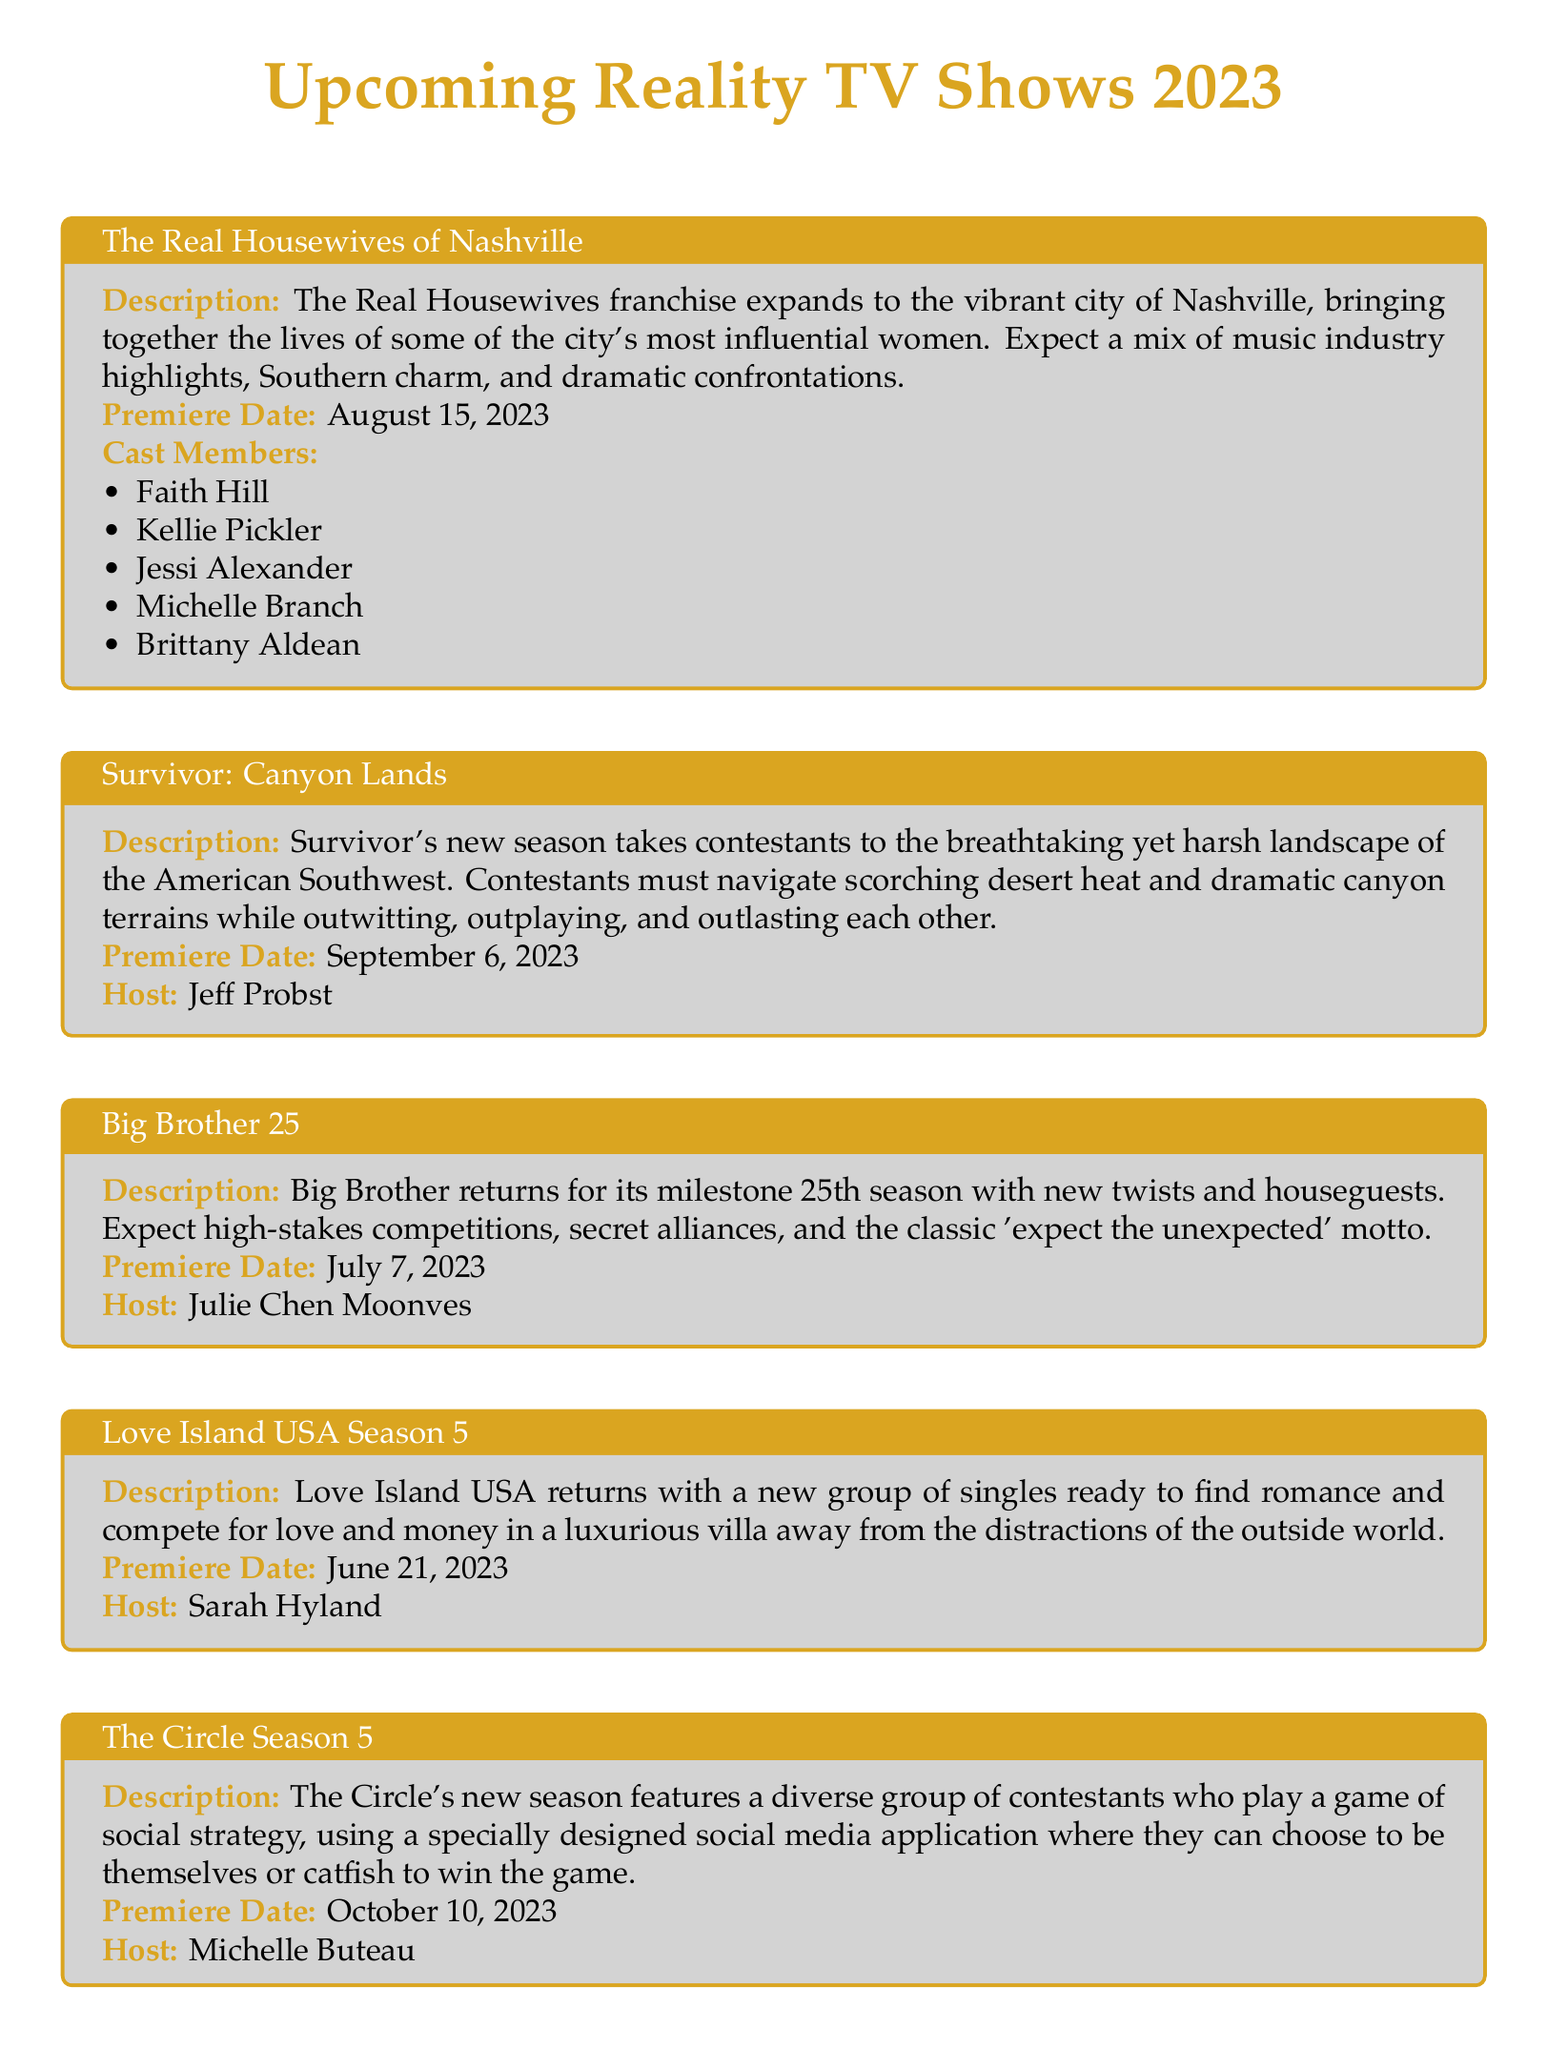What is the premiere date of The Real Housewives of Nashville? The premiere date for The Real Housewives of Nashville is specified in the document.
Answer: August 15, 2023 Who is the host of Survivor: Canyon Lands? The document lists the host for Survivor: Canyon Lands, which is Jeff Probst.
Answer: Jeff Probst How many cast members are in The Real Housewives of Nashville? The document provides a list of cast members for The Real Housewives of Nashville. There are five members listed.
Answer: 5 When does Love Island USA Season 5 premiere? The premiere date for Love Island USA Season 5 is clearly stated in the document.
Answer: June 21, 2023 What is the main theme of The Circle Season 5? The document describes the main theme of The Circle Season 5 as social strategy.
Answer: Social strategy Which show features hosts Tyra Banks and Alfonso Ribeiro? The document indicates that Tyra Banks and Alfonso Ribeiro are the hosts for a specific show.
Answer: Dancing with the Stars Season 32 What type of program is Big Brother 25? The document categorizes Big Brother 25 and its nature.
Answer: Reality competition What city does The Real Housewives franchise expand to in 2023? The document specifies the city that The Real Housewives franchise expands to.
Answer: Nashville 